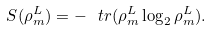Convert formula to latex. <formula><loc_0><loc_0><loc_500><loc_500>S ( \rho ^ { L } _ { m } ) = - \ t r ( \rho _ { m } ^ { L } \log _ { 2 } \rho _ { m } ^ { L } ) .</formula> 